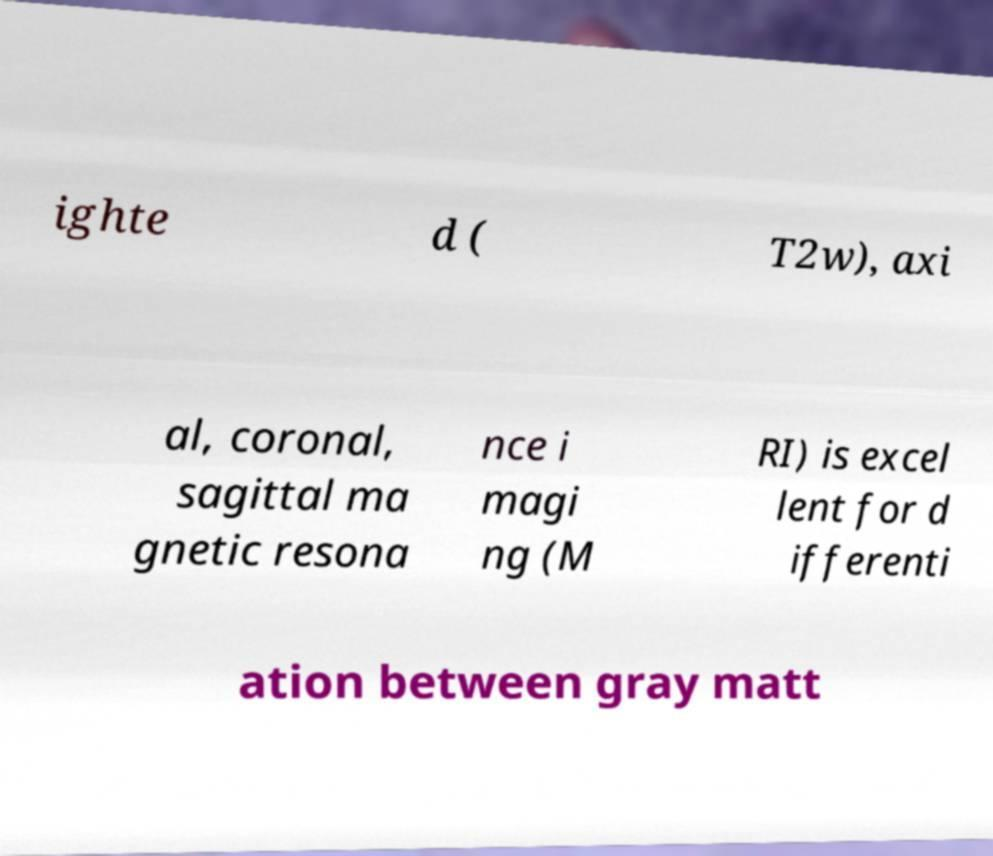Can you read and provide the text displayed in the image?This photo seems to have some interesting text. Can you extract and type it out for me? ighte d ( T2w), axi al, coronal, sagittal ma gnetic resona nce i magi ng (M RI) is excel lent for d ifferenti ation between gray matt 